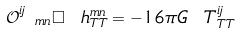Convert formula to latex. <formula><loc_0><loc_0><loc_500><loc_500>\mathcal { O } ^ { i j } _ { \ m n } \Box \ h ^ { m n } _ { T T } = - 1 6 \pi G \ T ^ { i j } _ { T T }</formula> 